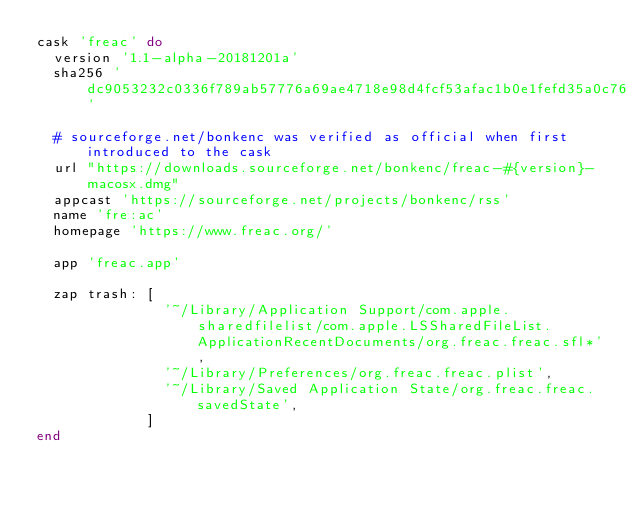Convert code to text. <code><loc_0><loc_0><loc_500><loc_500><_Ruby_>cask 'freac' do
  version '1.1-alpha-20181201a'
  sha256 'dc9053232c0336f789ab57776a69ae4718e98d4fcf53afac1b0e1fefd35a0c76'

  # sourceforge.net/bonkenc was verified as official when first introduced to the cask
  url "https://downloads.sourceforge.net/bonkenc/freac-#{version}-macosx.dmg"
  appcast 'https://sourceforge.net/projects/bonkenc/rss'
  name 'fre:ac'
  homepage 'https://www.freac.org/'

  app 'freac.app'

  zap trash: [
               '~/Library/Application Support/com.apple.sharedfilelist/com.apple.LSSharedFileList.ApplicationRecentDocuments/org.freac.freac.sfl*',
               '~/Library/Preferences/org.freac.freac.plist',
               '~/Library/Saved Application State/org.freac.freac.savedState',
             ]
end
</code> 